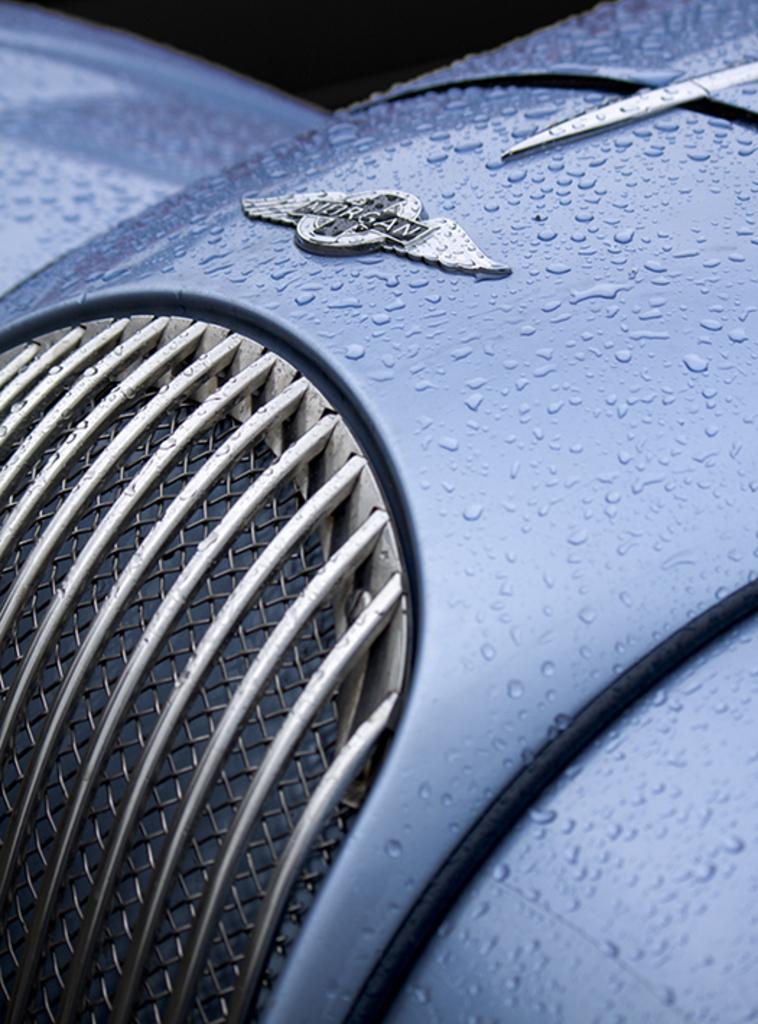In one or two sentences, can you explain what this image depicts? In this image a blue colour thing and on the top side of the image I can see something is written. 